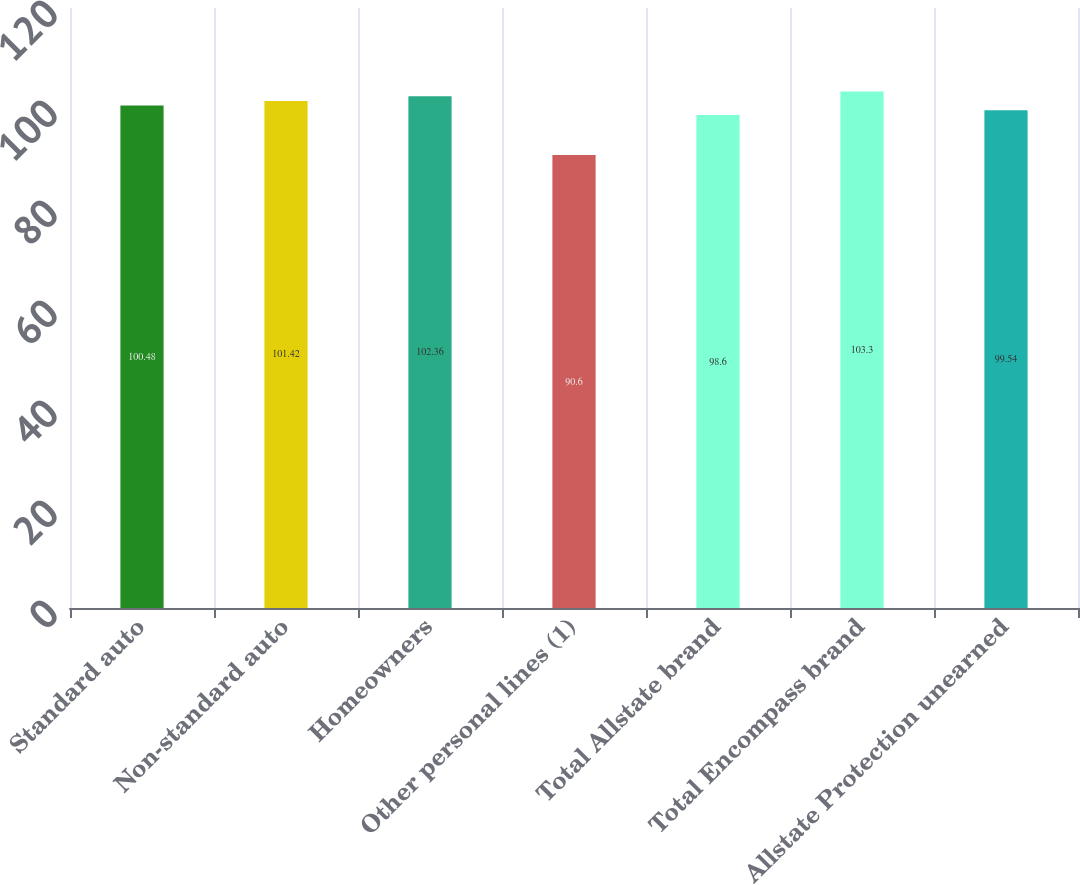<chart> <loc_0><loc_0><loc_500><loc_500><bar_chart><fcel>Standard auto<fcel>Non-standard auto<fcel>Homeowners<fcel>Other personal lines (1)<fcel>Total Allstate brand<fcel>Total Encompass brand<fcel>Allstate Protection unearned<nl><fcel>100.48<fcel>101.42<fcel>102.36<fcel>90.6<fcel>98.6<fcel>103.3<fcel>99.54<nl></chart> 